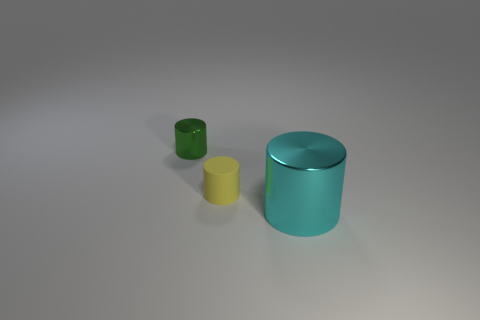Is there anything else that has the same material as the yellow thing?
Ensure brevity in your answer.  No. Is there anything else that is the same size as the cyan metallic thing?
Ensure brevity in your answer.  No. What number of green metal objects are the same shape as the small matte object?
Your answer should be compact. 1. There is a cylinder to the right of the yellow rubber cylinder; what is its material?
Ensure brevity in your answer.  Metal. Are there fewer big cyan metallic objects in front of the cyan metal cylinder than small green cylinders?
Offer a very short reply. Yes. Are any small purple objects visible?
Your answer should be very brief. No. What is the material of the tiny cylinder that is in front of the metallic object that is behind the yellow rubber cylinder?
Your response must be concise. Rubber. The big metallic cylinder is what color?
Your answer should be compact. Cyan. There is another yellow object that is the same shape as the large metallic thing; what size is it?
Your answer should be very brief. Small. What number of objects are metallic cylinders behind the big cylinder or cyan shiny objects?
Make the answer very short. 2. 